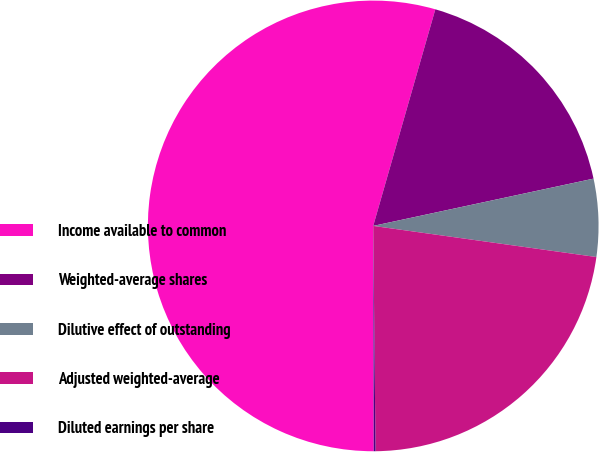Convert chart to OTSL. <chart><loc_0><loc_0><loc_500><loc_500><pie_chart><fcel>Income available to common<fcel>Weighted-average shares<fcel>Dilutive effect of outstanding<fcel>Adjusted weighted-average<fcel>Diluted earnings per share<nl><fcel>54.48%<fcel>17.19%<fcel>5.57%<fcel>22.63%<fcel>0.13%<nl></chart> 